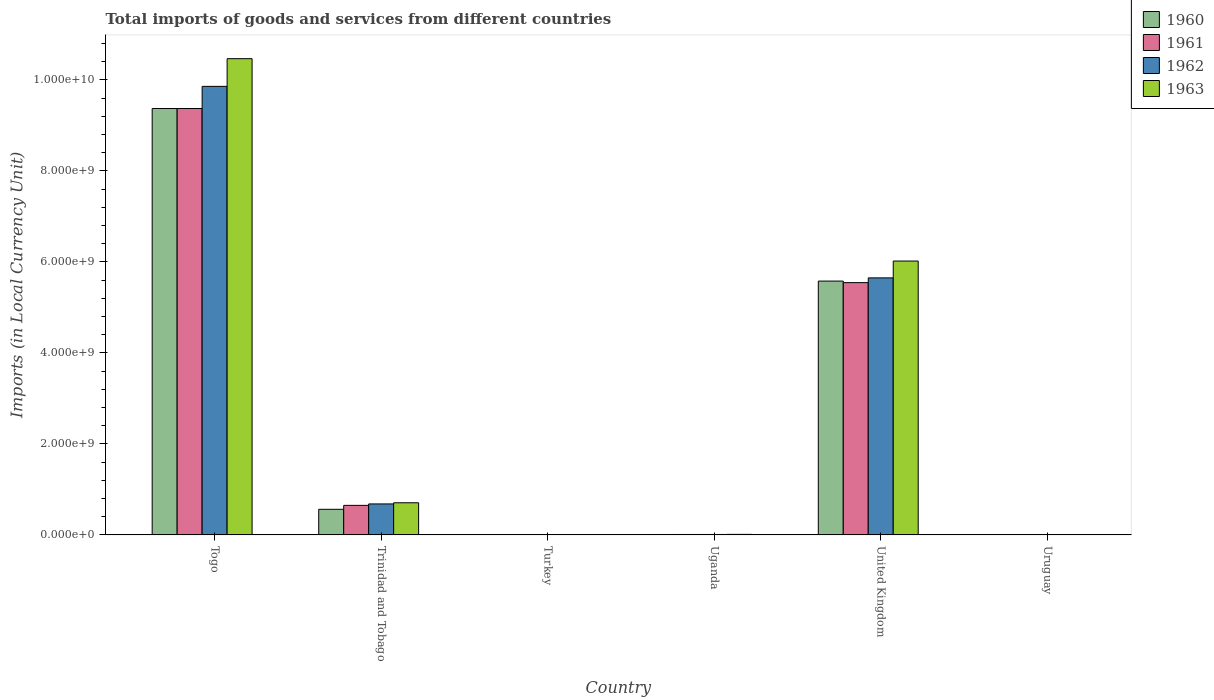How many bars are there on the 6th tick from the left?
Your answer should be very brief. 4. How many bars are there on the 2nd tick from the right?
Offer a terse response. 4. What is the label of the 2nd group of bars from the left?
Your answer should be compact. Trinidad and Tobago. In how many cases, is the number of bars for a given country not equal to the number of legend labels?
Make the answer very short. 0. What is the Amount of goods and services imports in 1963 in Togo?
Offer a terse response. 1.05e+1. Across all countries, what is the maximum Amount of goods and services imports in 1962?
Make the answer very short. 9.86e+09. Across all countries, what is the minimum Amount of goods and services imports in 1961?
Ensure brevity in your answer.  2600. In which country was the Amount of goods and services imports in 1960 maximum?
Provide a succinct answer. Togo. In which country was the Amount of goods and services imports in 1963 minimum?
Give a very brief answer. Uruguay. What is the total Amount of goods and services imports in 1960 in the graph?
Offer a very short reply. 1.55e+1. What is the difference between the Amount of goods and services imports in 1960 in Trinidad and Tobago and that in Uruguay?
Provide a succinct answer. 5.62e+08. What is the difference between the Amount of goods and services imports in 1962 in Uruguay and the Amount of goods and services imports in 1961 in Uganda?
Keep it short and to the point. -9.11e+06. What is the average Amount of goods and services imports in 1960 per country?
Make the answer very short. 2.59e+09. What is the difference between the Amount of goods and services imports of/in 1960 and Amount of goods and services imports of/in 1962 in Togo?
Your answer should be compact. -4.87e+08. In how many countries, is the Amount of goods and services imports in 1963 greater than 10000000000 LCU?
Keep it short and to the point. 1. What is the ratio of the Amount of goods and services imports in 1963 in Turkey to that in Uganda?
Provide a succinct answer. 0. Is the Amount of goods and services imports in 1961 in Uganda less than that in Uruguay?
Ensure brevity in your answer.  No. What is the difference between the highest and the second highest Amount of goods and services imports in 1960?
Offer a very short reply. 3.79e+09. What is the difference between the highest and the lowest Amount of goods and services imports in 1961?
Offer a very short reply. 9.37e+09. In how many countries, is the Amount of goods and services imports in 1962 greater than the average Amount of goods and services imports in 1962 taken over all countries?
Give a very brief answer. 2. Is the sum of the Amount of goods and services imports in 1962 in Togo and Uganda greater than the maximum Amount of goods and services imports in 1961 across all countries?
Your answer should be compact. Yes. What is the difference between two consecutive major ticks on the Y-axis?
Provide a succinct answer. 2.00e+09. Are the values on the major ticks of Y-axis written in scientific E-notation?
Your response must be concise. Yes. What is the title of the graph?
Give a very brief answer. Total imports of goods and services from different countries. Does "1998" appear as one of the legend labels in the graph?
Give a very brief answer. No. What is the label or title of the X-axis?
Your response must be concise. Country. What is the label or title of the Y-axis?
Give a very brief answer. Imports (in Local Currency Unit). What is the Imports (in Local Currency Unit) in 1960 in Togo?
Your response must be concise. 9.37e+09. What is the Imports (in Local Currency Unit) of 1961 in Togo?
Your answer should be very brief. 9.37e+09. What is the Imports (in Local Currency Unit) of 1962 in Togo?
Offer a very short reply. 9.86e+09. What is the Imports (in Local Currency Unit) of 1963 in Togo?
Your answer should be very brief. 1.05e+1. What is the Imports (in Local Currency Unit) in 1960 in Trinidad and Tobago?
Ensure brevity in your answer.  5.62e+08. What is the Imports (in Local Currency Unit) of 1961 in Trinidad and Tobago?
Make the answer very short. 6.49e+08. What is the Imports (in Local Currency Unit) in 1962 in Trinidad and Tobago?
Provide a succinct answer. 6.81e+08. What is the Imports (in Local Currency Unit) of 1963 in Trinidad and Tobago?
Offer a terse response. 7.06e+08. What is the Imports (in Local Currency Unit) in 1960 in Turkey?
Keep it short and to the point. 2500. What is the Imports (in Local Currency Unit) of 1961 in Turkey?
Provide a short and direct response. 4900. What is the Imports (in Local Currency Unit) of 1962 in Turkey?
Offer a very short reply. 6400. What is the Imports (in Local Currency Unit) in 1963 in Turkey?
Give a very brief answer. 6500. What is the Imports (in Local Currency Unit) of 1960 in Uganda?
Offer a terse response. 8.80e+06. What is the Imports (in Local Currency Unit) of 1961 in Uganda?
Offer a terse response. 9.12e+06. What is the Imports (in Local Currency Unit) of 1962 in Uganda?
Offer a terse response. 9.19e+06. What is the Imports (in Local Currency Unit) of 1963 in Uganda?
Your response must be concise. 1.18e+07. What is the Imports (in Local Currency Unit) of 1960 in United Kingdom?
Give a very brief answer. 5.58e+09. What is the Imports (in Local Currency Unit) of 1961 in United Kingdom?
Ensure brevity in your answer.  5.54e+09. What is the Imports (in Local Currency Unit) in 1962 in United Kingdom?
Offer a very short reply. 5.65e+09. What is the Imports (in Local Currency Unit) in 1963 in United Kingdom?
Give a very brief answer. 6.02e+09. What is the Imports (in Local Currency Unit) of 1960 in Uruguay?
Keep it short and to the point. 2700. What is the Imports (in Local Currency Unit) of 1961 in Uruguay?
Give a very brief answer. 2600. What is the Imports (in Local Currency Unit) in 1962 in Uruguay?
Your answer should be very brief. 2800. What is the Imports (in Local Currency Unit) in 1963 in Uruguay?
Offer a very short reply. 2800. Across all countries, what is the maximum Imports (in Local Currency Unit) in 1960?
Keep it short and to the point. 9.37e+09. Across all countries, what is the maximum Imports (in Local Currency Unit) in 1961?
Offer a very short reply. 9.37e+09. Across all countries, what is the maximum Imports (in Local Currency Unit) of 1962?
Ensure brevity in your answer.  9.86e+09. Across all countries, what is the maximum Imports (in Local Currency Unit) in 1963?
Your answer should be compact. 1.05e+1. Across all countries, what is the minimum Imports (in Local Currency Unit) in 1960?
Your response must be concise. 2500. Across all countries, what is the minimum Imports (in Local Currency Unit) in 1961?
Keep it short and to the point. 2600. Across all countries, what is the minimum Imports (in Local Currency Unit) in 1962?
Provide a succinct answer. 2800. Across all countries, what is the minimum Imports (in Local Currency Unit) of 1963?
Your answer should be very brief. 2800. What is the total Imports (in Local Currency Unit) in 1960 in the graph?
Ensure brevity in your answer.  1.55e+1. What is the total Imports (in Local Currency Unit) of 1961 in the graph?
Your answer should be compact. 1.56e+1. What is the total Imports (in Local Currency Unit) of 1962 in the graph?
Make the answer very short. 1.62e+1. What is the total Imports (in Local Currency Unit) of 1963 in the graph?
Your answer should be very brief. 1.72e+1. What is the difference between the Imports (in Local Currency Unit) of 1960 in Togo and that in Trinidad and Tobago?
Your answer should be compact. 8.81e+09. What is the difference between the Imports (in Local Currency Unit) in 1961 in Togo and that in Trinidad and Tobago?
Your answer should be compact. 8.72e+09. What is the difference between the Imports (in Local Currency Unit) of 1962 in Togo and that in Trinidad and Tobago?
Your answer should be compact. 9.18e+09. What is the difference between the Imports (in Local Currency Unit) in 1963 in Togo and that in Trinidad and Tobago?
Your answer should be compact. 9.76e+09. What is the difference between the Imports (in Local Currency Unit) in 1960 in Togo and that in Turkey?
Your response must be concise. 9.37e+09. What is the difference between the Imports (in Local Currency Unit) in 1961 in Togo and that in Turkey?
Ensure brevity in your answer.  9.37e+09. What is the difference between the Imports (in Local Currency Unit) in 1962 in Togo and that in Turkey?
Ensure brevity in your answer.  9.86e+09. What is the difference between the Imports (in Local Currency Unit) in 1963 in Togo and that in Turkey?
Your answer should be compact. 1.05e+1. What is the difference between the Imports (in Local Currency Unit) of 1960 in Togo and that in Uganda?
Offer a very short reply. 9.36e+09. What is the difference between the Imports (in Local Currency Unit) in 1961 in Togo and that in Uganda?
Ensure brevity in your answer.  9.36e+09. What is the difference between the Imports (in Local Currency Unit) in 1962 in Togo and that in Uganda?
Provide a short and direct response. 9.85e+09. What is the difference between the Imports (in Local Currency Unit) of 1963 in Togo and that in Uganda?
Offer a very short reply. 1.05e+1. What is the difference between the Imports (in Local Currency Unit) in 1960 in Togo and that in United Kingdom?
Make the answer very short. 3.79e+09. What is the difference between the Imports (in Local Currency Unit) in 1961 in Togo and that in United Kingdom?
Provide a short and direct response. 3.83e+09. What is the difference between the Imports (in Local Currency Unit) in 1962 in Togo and that in United Kingdom?
Your response must be concise. 4.21e+09. What is the difference between the Imports (in Local Currency Unit) of 1963 in Togo and that in United Kingdom?
Provide a short and direct response. 4.45e+09. What is the difference between the Imports (in Local Currency Unit) of 1960 in Togo and that in Uruguay?
Offer a terse response. 9.37e+09. What is the difference between the Imports (in Local Currency Unit) in 1961 in Togo and that in Uruguay?
Your response must be concise. 9.37e+09. What is the difference between the Imports (in Local Currency Unit) in 1962 in Togo and that in Uruguay?
Provide a succinct answer. 9.86e+09. What is the difference between the Imports (in Local Currency Unit) of 1963 in Togo and that in Uruguay?
Your response must be concise. 1.05e+1. What is the difference between the Imports (in Local Currency Unit) in 1960 in Trinidad and Tobago and that in Turkey?
Provide a succinct answer. 5.62e+08. What is the difference between the Imports (in Local Currency Unit) of 1961 in Trinidad and Tobago and that in Turkey?
Provide a short and direct response. 6.49e+08. What is the difference between the Imports (in Local Currency Unit) in 1962 in Trinidad and Tobago and that in Turkey?
Offer a terse response. 6.81e+08. What is the difference between the Imports (in Local Currency Unit) of 1963 in Trinidad and Tobago and that in Turkey?
Give a very brief answer. 7.06e+08. What is the difference between the Imports (in Local Currency Unit) of 1960 in Trinidad and Tobago and that in Uganda?
Give a very brief answer. 5.53e+08. What is the difference between the Imports (in Local Currency Unit) of 1961 in Trinidad and Tobago and that in Uganda?
Your response must be concise. 6.40e+08. What is the difference between the Imports (in Local Currency Unit) of 1962 in Trinidad and Tobago and that in Uganda?
Your answer should be compact. 6.71e+08. What is the difference between the Imports (in Local Currency Unit) of 1963 in Trinidad and Tobago and that in Uganda?
Provide a succinct answer. 6.94e+08. What is the difference between the Imports (in Local Currency Unit) in 1960 in Trinidad and Tobago and that in United Kingdom?
Offer a terse response. -5.02e+09. What is the difference between the Imports (in Local Currency Unit) in 1961 in Trinidad and Tobago and that in United Kingdom?
Keep it short and to the point. -4.89e+09. What is the difference between the Imports (in Local Currency Unit) of 1962 in Trinidad and Tobago and that in United Kingdom?
Make the answer very short. -4.97e+09. What is the difference between the Imports (in Local Currency Unit) of 1963 in Trinidad and Tobago and that in United Kingdom?
Your response must be concise. -5.31e+09. What is the difference between the Imports (in Local Currency Unit) of 1960 in Trinidad and Tobago and that in Uruguay?
Provide a short and direct response. 5.62e+08. What is the difference between the Imports (in Local Currency Unit) in 1961 in Trinidad and Tobago and that in Uruguay?
Provide a succinct answer. 6.49e+08. What is the difference between the Imports (in Local Currency Unit) in 1962 in Trinidad and Tobago and that in Uruguay?
Make the answer very short. 6.81e+08. What is the difference between the Imports (in Local Currency Unit) in 1963 in Trinidad and Tobago and that in Uruguay?
Provide a succinct answer. 7.06e+08. What is the difference between the Imports (in Local Currency Unit) of 1960 in Turkey and that in Uganda?
Keep it short and to the point. -8.80e+06. What is the difference between the Imports (in Local Currency Unit) of 1961 in Turkey and that in Uganda?
Offer a terse response. -9.11e+06. What is the difference between the Imports (in Local Currency Unit) of 1962 in Turkey and that in Uganda?
Make the answer very short. -9.18e+06. What is the difference between the Imports (in Local Currency Unit) of 1963 in Turkey and that in Uganda?
Ensure brevity in your answer.  -1.18e+07. What is the difference between the Imports (in Local Currency Unit) of 1960 in Turkey and that in United Kingdom?
Offer a very short reply. -5.58e+09. What is the difference between the Imports (in Local Currency Unit) in 1961 in Turkey and that in United Kingdom?
Offer a terse response. -5.54e+09. What is the difference between the Imports (in Local Currency Unit) of 1962 in Turkey and that in United Kingdom?
Your answer should be very brief. -5.65e+09. What is the difference between the Imports (in Local Currency Unit) of 1963 in Turkey and that in United Kingdom?
Give a very brief answer. -6.02e+09. What is the difference between the Imports (in Local Currency Unit) in 1960 in Turkey and that in Uruguay?
Your response must be concise. -200. What is the difference between the Imports (in Local Currency Unit) in 1961 in Turkey and that in Uruguay?
Your answer should be compact. 2300. What is the difference between the Imports (in Local Currency Unit) in 1962 in Turkey and that in Uruguay?
Offer a terse response. 3600. What is the difference between the Imports (in Local Currency Unit) of 1963 in Turkey and that in Uruguay?
Your answer should be compact. 3700. What is the difference between the Imports (in Local Currency Unit) in 1960 in Uganda and that in United Kingdom?
Ensure brevity in your answer.  -5.57e+09. What is the difference between the Imports (in Local Currency Unit) in 1961 in Uganda and that in United Kingdom?
Keep it short and to the point. -5.53e+09. What is the difference between the Imports (in Local Currency Unit) in 1962 in Uganda and that in United Kingdom?
Keep it short and to the point. -5.64e+09. What is the difference between the Imports (in Local Currency Unit) in 1963 in Uganda and that in United Kingdom?
Provide a short and direct response. -6.01e+09. What is the difference between the Imports (in Local Currency Unit) of 1960 in Uganda and that in Uruguay?
Ensure brevity in your answer.  8.80e+06. What is the difference between the Imports (in Local Currency Unit) of 1961 in Uganda and that in Uruguay?
Your answer should be very brief. 9.11e+06. What is the difference between the Imports (in Local Currency Unit) in 1962 in Uganda and that in Uruguay?
Provide a short and direct response. 9.18e+06. What is the difference between the Imports (in Local Currency Unit) of 1963 in Uganda and that in Uruguay?
Your answer should be compact. 1.18e+07. What is the difference between the Imports (in Local Currency Unit) of 1960 in United Kingdom and that in Uruguay?
Offer a terse response. 5.58e+09. What is the difference between the Imports (in Local Currency Unit) of 1961 in United Kingdom and that in Uruguay?
Give a very brief answer. 5.54e+09. What is the difference between the Imports (in Local Currency Unit) in 1962 in United Kingdom and that in Uruguay?
Offer a terse response. 5.65e+09. What is the difference between the Imports (in Local Currency Unit) in 1963 in United Kingdom and that in Uruguay?
Offer a terse response. 6.02e+09. What is the difference between the Imports (in Local Currency Unit) of 1960 in Togo and the Imports (in Local Currency Unit) of 1961 in Trinidad and Tobago?
Provide a short and direct response. 8.72e+09. What is the difference between the Imports (in Local Currency Unit) of 1960 in Togo and the Imports (in Local Currency Unit) of 1962 in Trinidad and Tobago?
Your answer should be compact. 8.69e+09. What is the difference between the Imports (in Local Currency Unit) of 1960 in Togo and the Imports (in Local Currency Unit) of 1963 in Trinidad and Tobago?
Provide a succinct answer. 8.66e+09. What is the difference between the Imports (in Local Currency Unit) of 1961 in Togo and the Imports (in Local Currency Unit) of 1962 in Trinidad and Tobago?
Your answer should be compact. 8.69e+09. What is the difference between the Imports (in Local Currency Unit) in 1961 in Togo and the Imports (in Local Currency Unit) in 1963 in Trinidad and Tobago?
Offer a terse response. 8.66e+09. What is the difference between the Imports (in Local Currency Unit) of 1962 in Togo and the Imports (in Local Currency Unit) of 1963 in Trinidad and Tobago?
Ensure brevity in your answer.  9.15e+09. What is the difference between the Imports (in Local Currency Unit) of 1960 in Togo and the Imports (in Local Currency Unit) of 1961 in Turkey?
Your answer should be very brief. 9.37e+09. What is the difference between the Imports (in Local Currency Unit) of 1960 in Togo and the Imports (in Local Currency Unit) of 1962 in Turkey?
Your response must be concise. 9.37e+09. What is the difference between the Imports (in Local Currency Unit) of 1960 in Togo and the Imports (in Local Currency Unit) of 1963 in Turkey?
Offer a terse response. 9.37e+09. What is the difference between the Imports (in Local Currency Unit) in 1961 in Togo and the Imports (in Local Currency Unit) in 1962 in Turkey?
Keep it short and to the point. 9.37e+09. What is the difference between the Imports (in Local Currency Unit) in 1961 in Togo and the Imports (in Local Currency Unit) in 1963 in Turkey?
Your answer should be very brief. 9.37e+09. What is the difference between the Imports (in Local Currency Unit) in 1962 in Togo and the Imports (in Local Currency Unit) in 1963 in Turkey?
Make the answer very short. 9.86e+09. What is the difference between the Imports (in Local Currency Unit) in 1960 in Togo and the Imports (in Local Currency Unit) in 1961 in Uganda?
Ensure brevity in your answer.  9.36e+09. What is the difference between the Imports (in Local Currency Unit) in 1960 in Togo and the Imports (in Local Currency Unit) in 1962 in Uganda?
Provide a succinct answer. 9.36e+09. What is the difference between the Imports (in Local Currency Unit) of 1960 in Togo and the Imports (in Local Currency Unit) of 1963 in Uganda?
Your answer should be very brief. 9.36e+09. What is the difference between the Imports (in Local Currency Unit) of 1961 in Togo and the Imports (in Local Currency Unit) of 1962 in Uganda?
Your answer should be compact. 9.36e+09. What is the difference between the Imports (in Local Currency Unit) in 1961 in Togo and the Imports (in Local Currency Unit) in 1963 in Uganda?
Give a very brief answer. 9.36e+09. What is the difference between the Imports (in Local Currency Unit) in 1962 in Togo and the Imports (in Local Currency Unit) in 1963 in Uganda?
Provide a short and direct response. 9.85e+09. What is the difference between the Imports (in Local Currency Unit) in 1960 in Togo and the Imports (in Local Currency Unit) in 1961 in United Kingdom?
Your response must be concise. 3.83e+09. What is the difference between the Imports (in Local Currency Unit) of 1960 in Togo and the Imports (in Local Currency Unit) of 1962 in United Kingdom?
Offer a very short reply. 3.72e+09. What is the difference between the Imports (in Local Currency Unit) in 1960 in Togo and the Imports (in Local Currency Unit) in 1963 in United Kingdom?
Make the answer very short. 3.35e+09. What is the difference between the Imports (in Local Currency Unit) in 1961 in Togo and the Imports (in Local Currency Unit) in 1962 in United Kingdom?
Give a very brief answer. 3.72e+09. What is the difference between the Imports (in Local Currency Unit) of 1961 in Togo and the Imports (in Local Currency Unit) of 1963 in United Kingdom?
Offer a very short reply. 3.35e+09. What is the difference between the Imports (in Local Currency Unit) of 1962 in Togo and the Imports (in Local Currency Unit) of 1963 in United Kingdom?
Provide a succinct answer. 3.84e+09. What is the difference between the Imports (in Local Currency Unit) of 1960 in Togo and the Imports (in Local Currency Unit) of 1961 in Uruguay?
Your response must be concise. 9.37e+09. What is the difference between the Imports (in Local Currency Unit) in 1960 in Togo and the Imports (in Local Currency Unit) in 1962 in Uruguay?
Keep it short and to the point. 9.37e+09. What is the difference between the Imports (in Local Currency Unit) of 1960 in Togo and the Imports (in Local Currency Unit) of 1963 in Uruguay?
Offer a very short reply. 9.37e+09. What is the difference between the Imports (in Local Currency Unit) in 1961 in Togo and the Imports (in Local Currency Unit) in 1962 in Uruguay?
Keep it short and to the point. 9.37e+09. What is the difference between the Imports (in Local Currency Unit) of 1961 in Togo and the Imports (in Local Currency Unit) of 1963 in Uruguay?
Make the answer very short. 9.37e+09. What is the difference between the Imports (in Local Currency Unit) of 1962 in Togo and the Imports (in Local Currency Unit) of 1963 in Uruguay?
Provide a short and direct response. 9.86e+09. What is the difference between the Imports (in Local Currency Unit) in 1960 in Trinidad and Tobago and the Imports (in Local Currency Unit) in 1961 in Turkey?
Make the answer very short. 5.62e+08. What is the difference between the Imports (in Local Currency Unit) of 1960 in Trinidad and Tobago and the Imports (in Local Currency Unit) of 1962 in Turkey?
Offer a very short reply. 5.62e+08. What is the difference between the Imports (in Local Currency Unit) in 1960 in Trinidad and Tobago and the Imports (in Local Currency Unit) in 1963 in Turkey?
Offer a very short reply. 5.62e+08. What is the difference between the Imports (in Local Currency Unit) of 1961 in Trinidad and Tobago and the Imports (in Local Currency Unit) of 1962 in Turkey?
Ensure brevity in your answer.  6.49e+08. What is the difference between the Imports (in Local Currency Unit) of 1961 in Trinidad and Tobago and the Imports (in Local Currency Unit) of 1963 in Turkey?
Provide a succinct answer. 6.49e+08. What is the difference between the Imports (in Local Currency Unit) of 1962 in Trinidad and Tobago and the Imports (in Local Currency Unit) of 1963 in Turkey?
Make the answer very short. 6.81e+08. What is the difference between the Imports (in Local Currency Unit) in 1960 in Trinidad and Tobago and the Imports (in Local Currency Unit) in 1961 in Uganda?
Make the answer very short. 5.53e+08. What is the difference between the Imports (in Local Currency Unit) in 1960 in Trinidad and Tobago and the Imports (in Local Currency Unit) in 1962 in Uganda?
Provide a succinct answer. 5.53e+08. What is the difference between the Imports (in Local Currency Unit) of 1960 in Trinidad and Tobago and the Imports (in Local Currency Unit) of 1963 in Uganda?
Your response must be concise. 5.50e+08. What is the difference between the Imports (in Local Currency Unit) in 1961 in Trinidad and Tobago and the Imports (in Local Currency Unit) in 1962 in Uganda?
Make the answer very short. 6.40e+08. What is the difference between the Imports (in Local Currency Unit) in 1961 in Trinidad and Tobago and the Imports (in Local Currency Unit) in 1963 in Uganda?
Your response must be concise. 6.37e+08. What is the difference between the Imports (in Local Currency Unit) of 1962 in Trinidad and Tobago and the Imports (in Local Currency Unit) of 1963 in Uganda?
Give a very brief answer. 6.69e+08. What is the difference between the Imports (in Local Currency Unit) in 1960 in Trinidad and Tobago and the Imports (in Local Currency Unit) in 1961 in United Kingdom?
Give a very brief answer. -4.98e+09. What is the difference between the Imports (in Local Currency Unit) of 1960 in Trinidad and Tobago and the Imports (in Local Currency Unit) of 1962 in United Kingdom?
Offer a terse response. -5.09e+09. What is the difference between the Imports (in Local Currency Unit) in 1960 in Trinidad and Tobago and the Imports (in Local Currency Unit) in 1963 in United Kingdom?
Offer a terse response. -5.46e+09. What is the difference between the Imports (in Local Currency Unit) in 1961 in Trinidad and Tobago and the Imports (in Local Currency Unit) in 1962 in United Kingdom?
Your response must be concise. -5.00e+09. What is the difference between the Imports (in Local Currency Unit) in 1961 in Trinidad and Tobago and the Imports (in Local Currency Unit) in 1963 in United Kingdom?
Provide a succinct answer. -5.37e+09. What is the difference between the Imports (in Local Currency Unit) in 1962 in Trinidad and Tobago and the Imports (in Local Currency Unit) in 1963 in United Kingdom?
Provide a succinct answer. -5.34e+09. What is the difference between the Imports (in Local Currency Unit) in 1960 in Trinidad and Tobago and the Imports (in Local Currency Unit) in 1961 in Uruguay?
Ensure brevity in your answer.  5.62e+08. What is the difference between the Imports (in Local Currency Unit) of 1960 in Trinidad and Tobago and the Imports (in Local Currency Unit) of 1962 in Uruguay?
Your answer should be compact. 5.62e+08. What is the difference between the Imports (in Local Currency Unit) of 1960 in Trinidad and Tobago and the Imports (in Local Currency Unit) of 1963 in Uruguay?
Make the answer very short. 5.62e+08. What is the difference between the Imports (in Local Currency Unit) of 1961 in Trinidad and Tobago and the Imports (in Local Currency Unit) of 1962 in Uruguay?
Offer a very short reply. 6.49e+08. What is the difference between the Imports (in Local Currency Unit) of 1961 in Trinidad and Tobago and the Imports (in Local Currency Unit) of 1963 in Uruguay?
Give a very brief answer. 6.49e+08. What is the difference between the Imports (in Local Currency Unit) in 1962 in Trinidad and Tobago and the Imports (in Local Currency Unit) in 1963 in Uruguay?
Keep it short and to the point. 6.81e+08. What is the difference between the Imports (in Local Currency Unit) in 1960 in Turkey and the Imports (in Local Currency Unit) in 1961 in Uganda?
Offer a very short reply. -9.11e+06. What is the difference between the Imports (in Local Currency Unit) in 1960 in Turkey and the Imports (in Local Currency Unit) in 1962 in Uganda?
Your answer should be very brief. -9.18e+06. What is the difference between the Imports (in Local Currency Unit) of 1960 in Turkey and the Imports (in Local Currency Unit) of 1963 in Uganda?
Give a very brief answer. -1.18e+07. What is the difference between the Imports (in Local Currency Unit) of 1961 in Turkey and the Imports (in Local Currency Unit) of 1962 in Uganda?
Provide a short and direct response. -9.18e+06. What is the difference between the Imports (in Local Currency Unit) in 1961 in Turkey and the Imports (in Local Currency Unit) in 1963 in Uganda?
Ensure brevity in your answer.  -1.18e+07. What is the difference between the Imports (in Local Currency Unit) of 1962 in Turkey and the Imports (in Local Currency Unit) of 1963 in Uganda?
Provide a succinct answer. -1.18e+07. What is the difference between the Imports (in Local Currency Unit) in 1960 in Turkey and the Imports (in Local Currency Unit) in 1961 in United Kingdom?
Offer a terse response. -5.54e+09. What is the difference between the Imports (in Local Currency Unit) of 1960 in Turkey and the Imports (in Local Currency Unit) of 1962 in United Kingdom?
Make the answer very short. -5.65e+09. What is the difference between the Imports (in Local Currency Unit) of 1960 in Turkey and the Imports (in Local Currency Unit) of 1963 in United Kingdom?
Your response must be concise. -6.02e+09. What is the difference between the Imports (in Local Currency Unit) in 1961 in Turkey and the Imports (in Local Currency Unit) in 1962 in United Kingdom?
Your answer should be very brief. -5.65e+09. What is the difference between the Imports (in Local Currency Unit) of 1961 in Turkey and the Imports (in Local Currency Unit) of 1963 in United Kingdom?
Offer a very short reply. -6.02e+09. What is the difference between the Imports (in Local Currency Unit) in 1962 in Turkey and the Imports (in Local Currency Unit) in 1963 in United Kingdom?
Offer a very short reply. -6.02e+09. What is the difference between the Imports (in Local Currency Unit) of 1960 in Turkey and the Imports (in Local Currency Unit) of 1961 in Uruguay?
Your answer should be very brief. -100. What is the difference between the Imports (in Local Currency Unit) in 1960 in Turkey and the Imports (in Local Currency Unit) in 1962 in Uruguay?
Your answer should be compact. -300. What is the difference between the Imports (in Local Currency Unit) of 1960 in Turkey and the Imports (in Local Currency Unit) of 1963 in Uruguay?
Give a very brief answer. -300. What is the difference between the Imports (in Local Currency Unit) of 1961 in Turkey and the Imports (in Local Currency Unit) of 1962 in Uruguay?
Provide a succinct answer. 2100. What is the difference between the Imports (in Local Currency Unit) of 1961 in Turkey and the Imports (in Local Currency Unit) of 1963 in Uruguay?
Offer a very short reply. 2100. What is the difference between the Imports (in Local Currency Unit) of 1962 in Turkey and the Imports (in Local Currency Unit) of 1963 in Uruguay?
Offer a very short reply. 3600. What is the difference between the Imports (in Local Currency Unit) in 1960 in Uganda and the Imports (in Local Currency Unit) in 1961 in United Kingdom?
Make the answer very short. -5.54e+09. What is the difference between the Imports (in Local Currency Unit) in 1960 in Uganda and the Imports (in Local Currency Unit) in 1962 in United Kingdom?
Make the answer very short. -5.64e+09. What is the difference between the Imports (in Local Currency Unit) of 1960 in Uganda and the Imports (in Local Currency Unit) of 1963 in United Kingdom?
Offer a very short reply. -6.01e+09. What is the difference between the Imports (in Local Currency Unit) of 1961 in Uganda and the Imports (in Local Currency Unit) of 1962 in United Kingdom?
Ensure brevity in your answer.  -5.64e+09. What is the difference between the Imports (in Local Currency Unit) in 1961 in Uganda and the Imports (in Local Currency Unit) in 1963 in United Kingdom?
Your answer should be very brief. -6.01e+09. What is the difference between the Imports (in Local Currency Unit) of 1962 in Uganda and the Imports (in Local Currency Unit) of 1963 in United Kingdom?
Your answer should be compact. -6.01e+09. What is the difference between the Imports (in Local Currency Unit) in 1960 in Uganda and the Imports (in Local Currency Unit) in 1961 in Uruguay?
Provide a succinct answer. 8.80e+06. What is the difference between the Imports (in Local Currency Unit) in 1960 in Uganda and the Imports (in Local Currency Unit) in 1962 in Uruguay?
Offer a very short reply. 8.80e+06. What is the difference between the Imports (in Local Currency Unit) of 1960 in Uganda and the Imports (in Local Currency Unit) of 1963 in Uruguay?
Your answer should be very brief. 8.80e+06. What is the difference between the Imports (in Local Currency Unit) of 1961 in Uganda and the Imports (in Local Currency Unit) of 1962 in Uruguay?
Give a very brief answer. 9.11e+06. What is the difference between the Imports (in Local Currency Unit) in 1961 in Uganda and the Imports (in Local Currency Unit) in 1963 in Uruguay?
Your response must be concise. 9.11e+06. What is the difference between the Imports (in Local Currency Unit) of 1962 in Uganda and the Imports (in Local Currency Unit) of 1963 in Uruguay?
Your response must be concise. 9.18e+06. What is the difference between the Imports (in Local Currency Unit) in 1960 in United Kingdom and the Imports (in Local Currency Unit) in 1961 in Uruguay?
Make the answer very short. 5.58e+09. What is the difference between the Imports (in Local Currency Unit) of 1960 in United Kingdom and the Imports (in Local Currency Unit) of 1962 in Uruguay?
Make the answer very short. 5.58e+09. What is the difference between the Imports (in Local Currency Unit) in 1960 in United Kingdom and the Imports (in Local Currency Unit) in 1963 in Uruguay?
Keep it short and to the point. 5.58e+09. What is the difference between the Imports (in Local Currency Unit) in 1961 in United Kingdom and the Imports (in Local Currency Unit) in 1962 in Uruguay?
Keep it short and to the point. 5.54e+09. What is the difference between the Imports (in Local Currency Unit) in 1961 in United Kingdom and the Imports (in Local Currency Unit) in 1963 in Uruguay?
Make the answer very short. 5.54e+09. What is the difference between the Imports (in Local Currency Unit) in 1962 in United Kingdom and the Imports (in Local Currency Unit) in 1963 in Uruguay?
Provide a succinct answer. 5.65e+09. What is the average Imports (in Local Currency Unit) of 1960 per country?
Make the answer very short. 2.59e+09. What is the average Imports (in Local Currency Unit) of 1961 per country?
Ensure brevity in your answer.  2.60e+09. What is the average Imports (in Local Currency Unit) of 1962 per country?
Provide a succinct answer. 2.70e+09. What is the average Imports (in Local Currency Unit) in 1963 per country?
Your answer should be compact. 2.87e+09. What is the difference between the Imports (in Local Currency Unit) in 1960 and Imports (in Local Currency Unit) in 1962 in Togo?
Give a very brief answer. -4.87e+08. What is the difference between the Imports (in Local Currency Unit) in 1960 and Imports (in Local Currency Unit) in 1963 in Togo?
Offer a terse response. -1.10e+09. What is the difference between the Imports (in Local Currency Unit) of 1961 and Imports (in Local Currency Unit) of 1962 in Togo?
Provide a short and direct response. -4.87e+08. What is the difference between the Imports (in Local Currency Unit) in 1961 and Imports (in Local Currency Unit) in 1963 in Togo?
Provide a short and direct response. -1.10e+09. What is the difference between the Imports (in Local Currency Unit) of 1962 and Imports (in Local Currency Unit) of 1963 in Togo?
Your response must be concise. -6.08e+08. What is the difference between the Imports (in Local Currency Unit) of 1960 and Imports (in Local Currency Unit) of 1961 in Trinidad and Tobago?
Give a very brief answer. -8.67e+07. What is the difference between the Imports (in Local Currency Unit) in 1960 and Imports (in Local Currency Unit) in 1962 in Trinidad and Tobago?
Give a very brief answer. -1.18e+08. What is the difference between the Imports (in Local Currency Unit) in 1960 and Imports (in Local Currency Unit) in 1963 in Trinidad and Tobago?
Your answer should be very brief. -1.44e+08. What is the difference between the Imports (in Local Currency Unit) of 1961 and Imports (in Local Currency Unit) of 1962 in Trinidad and Tobago?
Ensure brevity in your answer.  -3.17e+07. What is the difference between the Imports (in Local Currency Unit) in 1961 and Imports (in Local Currency Unit) in 1963 in Trinidad and Tobago?
Offer a very short reply. -5.69e+07. What is the difference between the Imports (in Local Currency Unit) in 1962 and Imports (in Local Currency Unit) in 1963 in Trinidad and Tobago?
Offer a terse response. -2.52e+07. What is the difference between the Imports (in Local Currency Unit) in 1960 and Imports (in Local Currency Unit) in 1961 in Turkey?
Give a very brief answer. -2400. What is the difference between the Imports (in Local Currency Unit) of 1960 and Imports (in Local Currency Unit) of 1962 in Turkey?
Your answer should be very brief. -3900. What is the difference between the Imports (in Local Currency Unit) of 1960 and Imports (in Local Currency Unit) of 1963 in Turkey?
Keep it short and to the point. -4000. What is the difference between the Imports (in Local Currency Unit) in 1961 and Imports (in Local Currency Unit) in 1962 in Turkey?
Offer a very short reply. -1500. What is the difference between the Imports (in Local Currency Unit) of 1961 and Imports (in Local Currency Unit) of 1963 in Turkey?
Keep it short and to the point. -1600. What is the difference between the Imports (in Local Currency Unit) in 1962 and Imports (in Local Currency Unit) in 1963 in Turkey?
Provide a short and direct response. -100. What is the difference between the Imports (in Local Currency Unit) in 1960 and Imports (in Local Currency Unit) in 1961 in Uganda?
Your answer should be compact. -3.13e+05. What is the difference between the Imports (in Local Currency Unit) of 1960 and Imports (in Local Currency Unit) of 1962 in Uganda?
Provide a succinct answer. -3.83e+05. What is the difference between the Imports (in Local Currency Unit) in 1960 and Imports (in Local Currency Unit) in 1963 in Uganda?
Your answer should be very brief. -2.95e+06. What is the difference between the Imports (in Local Currency Unit) in 1961 and Imports (in Local Currency Unit) in 1962 in Uganda?
Keep it short and to the point. -7.06e+04. What is the difference between the Imports (in Local Currency Unit) in 1961 and Imports (in Local Currency Unit) in 1963 in Uganda?
Keep it short and to the point. -2.64e+06. What is the difference between the Imports (in Local Currency Unit) of 1962 and Imports (in Local Currency Unit) of 1963 in Uganda?
Offer a terse response. -2.57e+06. What is the difference between the Imports (in Local Currency Unit) in 1960 and Imports (in Local Currency Unit) in 1961 in United Kingdom?
Offer a very short reply. 3.38e+07. What is the difference between the Imports (in Local Currency Unit) in 1960 and Imports (in Local Currency Unit) in 1962 in United Kingdom?
Your response must be concise. -7.06e+07. What is the difference between the Imports (in Local Currency Unit) in 1960 and Imports (in Local Currency Unit) in 1963 in United Kingdom?
Keep it short and to the point. -4.41e+08. What is the difference between the Imports (in Local Currency Unit) in 1961 and Imports (in Local Currency Unit) in 1962 in United Kingdom?
Offer a terse response. -1.04e+08. What is the difference between the Imports (in Local Currency Unit) of 1961 and Imports (in Local Currency Unit) of 1963 in United Kingdom?
Make the answer very short. -4.75e+08. What is the difference between the Imports (in Local Currency Unit) in 1962 and Imports (in Local Currency Unit) in 1963 in United Kingdom?
Provide a succinct answer. -3.70e+08. What is the difference between the Imports (in Local Currency Unit) of 1960 and Imports (in Local Currency Unit) of 1962 in Uruguay?
Provide a succinct answer. -100. What is the difference between the Imports (in Local Currency Unit) in 1960 and Imports (in Local Currency Unit) in 1963 in Uruguay?
Provide a succinct answer. -100. What is the difference between the Imports (in Local Currency Unit) in 1961 and Imports (in Local Currency Unit) in 1962 in Uruguay?
Keep it short and to the point. -200. What is the difference between the Imports (in Local Currency Unit) of 1961 and Imports (in Local Currency Unit) of 1963 in Uruguay?
Offer a terse response. -200. What is the difference between the Imports (in Local Currency Unit) of 1962 and Imports (in Local Currency Unit) of 1963 in Uruguay?
Provide a short and direct response. 0. What is the ratio of the Imports (in Local Currency Unit) of 1960 in Togo to that in Trinidad and Tobago?
Your response must be concise. 16.67. What is the ratio of the Imports (in Local Currency Unit) of 1961 in Togo to that in Trinidad and Tobago?
Offer a terse response. 14.44. What is the ratio of the Imports (in Local Currency Unit) of 1962 in Togo to that in Trinidad and Tobago?
Make the answer very short. 14.48. What is the ratio of the Imports (in Local Currency Unit) of 1963 in Togo to that in Trinidad and Tobago?
Offer a terse response. 14.83. What is the ratio of the Imports (in Local Currency Unit) of 1960 in Togo to that in Turkey?
Your answer should be compact. 3.75e+06. What is the ratio of the Imports (in Local Currency Unit) in 1961 in Togo to that in Turkey?
Offer a terse response. 1.91e+06. What is the ratio of the Imports (in Local Currency Unit) of 1962 in Togo to that in Turkey?
Give a very brief answer. 1.54e+06. What is the ratio of the Imports (in Local Currency Unit) of 1963 in Togo to that in Turkey?
Give a very brief answer. 1.61e+06. What is the ratio of the Imports (in Local Currency Unit) of 1960 in Togo to that in Uganda?
Ensure brevity in your answer.  1064.29. What is the ratio of the Imports (in Local Currency Unit) in 1961 in Togo to that in Uganda?
Your answer should be very brief. 1027.79. What is the ratio of the Imports (in Local Currency Unit) in 1962 in Togo to that in Uganda?
Offer a very short reply. 1072.87. What is the ratio of the Imports (in Local Currency Unit) of 1963 in Togo to that in Uganda?
Your response must be concise. 889.99. What is the ratio of the Imports (in Local Currency Unit) of 1960 in Togo to that in United Kingdom?
Provide a succinct answer. 1.68. What is the ratio of the Imports (in Local Currency Unit) in 1961 in Togo to that in United Kingdom?
Offer a terse response. 1.69. What is the ratio of the Imports (in Local Currency Unit) in 1962 in Togo to that in United Kingdom?
Keep it short and to the point. 1.75. What is the ratio of the Imports (in Local Currency Unit) in 1963 in Togo to that in United Kingdom?
Ensure brevity in your answer.  1.74. What is the ratio of the Imports (in Local Currency Unit) in 1960 in Togo to that in Uruguay?
Provide a short and direct response. 3.47e+06. What is the ratio of the Imports (in Local Currency Unit) of 1961 in Togo to that in Uruguay?
Give a very brief answer. 3.60e+06. What is the ratio of the Imports (in Local Currency Unit) in 1962 in Togo to that in Uruguay?
Your answer should be compact. 3.52e+06. What is the ratio of the Imports (in Local Currency Unit) of 1963 in Togo to that in Uruguay?
Ensure brevity in your answer.  3.74e+06. What is the ratio of the Imports (in Local Currency Unit) of 1960 in Trinidad and Tobago to that in Turkey?
Keep it short and to the point. 2.25e+05. What is the ratio of the Imports (in Local Currency Unit) of 1961 in Trinidad and Tobago to that in Turkey?
Keep it short and to the point. 1.32e+05. What is the ratio of the Imports (in Local Currency Unit) of 1962 in Trinidad and Tobago to that in Turkey?
Make the answer very short. 1.06e+05. What is the ratio of the Imports (in Local Currency Unit) in 1963 in Trinidad and Tobago to that in Turkey?
Make the answer very short. 1.09e+05. What is the ratio of the Imports (in Local Currency Unit) in 1960 in Trinidad and Tobago to that in Uganda?
Provide a succinct answer. 63.86. What is the ratio of the Imports (in Local Currency Unit) of 1961 in Trinidad and Tobago to that in Uganda?
Make the answer very short. 71.18. What is the ratio of the Imports (in Local Currency Unit) in 1962 in Trinidad and Tobago to that in Uganda?
Your answer should be very brief. 74.08. What is the ratio of the Imports (in Local Currency Unit) of 1963 in Trinidad and Tobago to that in Uganda?
Provide a short and direct response. 60.02. What is the ratio of the Imports (in Local Currency Unit) of 1960 in Trinidad and Tobago to that in United Kingdom?
Your response must be concise. 0.1. What is the ratio of the Imports (in Local Currency Unit) of 1961 in Trinidad and Tobago to that in United Kingdom?
Your response must be concise. 0.12. What is the ratio of the Imports (in Local Currency Unit) of 1962 in Trinidad and Tobago to that in United Kingdom?
Offer a very short reply. 0.12. What is the ratio of the Imports (in Local Currency Unit) in 1963 in Trinidad and Tobago to that in United Kingdom?
Make the answer very short. 0.12. What is the ratio of the Imports (in Local Currency Unit) in 1960 in Trinidad and Tobago to that in Uruguay?
Provide a short and direct response. 2.08e+05. What is the ratio of the Imports (in Local Currency Unit) in 1961 in Trinidad and Tobago to that in Uruguay?
Your response must be concise. 2.50e+05. What is the ratio of the Imports (in Local Currency Unit) in 1962 in Trinidad and Tobago to that in Uruguay?
Make the answer very short. 2.43e+05. What is the ratio of the Imports (in Local Currency Unit) in 1963 in Trinidad and Tobago to that in Uruguay?
Offer a very short reply. 2.52e+05. What is the ratio of the Imports (in Local Currency Unit) in 1961 in Turkey to that in Uganda?
Make the answer very short. 0. What is the ratio of the Imports (in Local Currency Unit) of 1962 in Turkey to that in Uganda?
Provide a succinct answer. 0. What is the ratio of the Imports (in Local Currency Unit) in 1963 in Turkey to that in Uganda?
Keep it short and to the point. 0. What is the ratio of the Imports (in Local Currency Unit) of 1960 in Turkey to that in United Kingdom?
Offer a terse response. 0. What is the ratio of the Imports (in Local Currency Unit) of 1960 in Turkey to that in Uruguay?
Make the answer very short. 0.93. What is the ratio of the Imports (in Local Currency Unit) in 1961 in Turkey to that in Uruguay?
Make the answer very short. 1.88. What is the ratio of the Imports (in Local Currency Unit) of 1962 in Turkey to that in Uruguay?
Offer a terse response. 2.29. What is the ratio of the Imports (in Local Currency Unit) of 1963 in Turkey to that in Uruguay?
Give a very brief answer. 2.32. What is the ratio of the Imports (in Local Currency Unit) in 1960 in Uganda to that in United Kingdom?
Give a very brief answer. 0. What is the ratio of the Imports (in Local Currency Unit) in 1961 in Uganda to that in United Kingdom?
Offer a very short reply. 0. What is the ratio of the Imports (in Local Currency Unit) of 1962 in Uganda to that in United Kingdom?
Keep it short and to the point. 0. What is the ratio of the Imports (in Local Currency Unit) of 1963 in Uganda to that in United Kingdom?
Ensure brevity in your answer.  0. What is the ratio of the Imports (in Local Currency Unit) in 1960 in Uganda to that in Uruguay?
Your answer should be compact. 3260.74. What is the ratio of the Imports (in Local Currency Unit) in 1961 in Uganda to that in Uruguay?
Your response must be concise. 3506.42. What is the ratio of the Imports (in Local Currency Unit) of 1962 in Uganda to that in Uruguay?
Your answer should be very brief. 3281.18. What is the ratio of the Imports (in Local Currency Unit) of 1963 in Uganda to that in Uruguay?
Your answer should be very brief. 4199.61. What is the ratio of the Imports (in Local Currency Unit) in 1960 in United Kingdom to that in Uruguay?
Your answer should be compact. 2.07e+06. What is the ratio of the Imports (in Local Currency Unit) of 1961 in United Kingdom to that in Uruguay?
Provide a succinct answer. 2.13e+06. What is the ratio of the Imports (in Local Currency Unit) in 1962 in United Kingdom to that in Uruguay?
Keep it short and to the point. 2.02e+06. What is the ratio of the Imports (in Local Currency Unit) in 1963 in United Kingdom to that in Uruguay?
Keep it short and to the point. 2.15e+06. What is the difference between the highest and the second highest Imports (in Local Currency Unit) in 1960?
Provide a short and direct response. 3.79e+09. What is the difference between the highest and the second highest Imports (in Local Currency Unit) in 1961?
Ensure brevity in your answer.  3.83e+09. What is the difference between the highest and the second highest Imports (in Local Currency Unit) of 1962?
Give a very brief answer. 4.21e+09. What is the difference between the highest and the second highest Imports (in Local Currency Unit) of 1963?
Provide a short and direct response. 4.45e+09. What is the difference between the highest and the lowest Imports (in Local Currency Unit) of 1960?
Offer a very short reply. 9.37e+09. What is the difference between the highest and the lowest Imports (in Local Currency Unit) of 1961?
Ensure brevity in your answer.  9.37e+09. What is the difference between the highest and the lowest Imports (in Local Currency Unit) of 1962?
Offer a terse response. 9.86e+09. What is the difference between the highest and the lowest Imports (in Local Currency Unit) in 1963?
Your answer should be compact. 1.05e+1. 